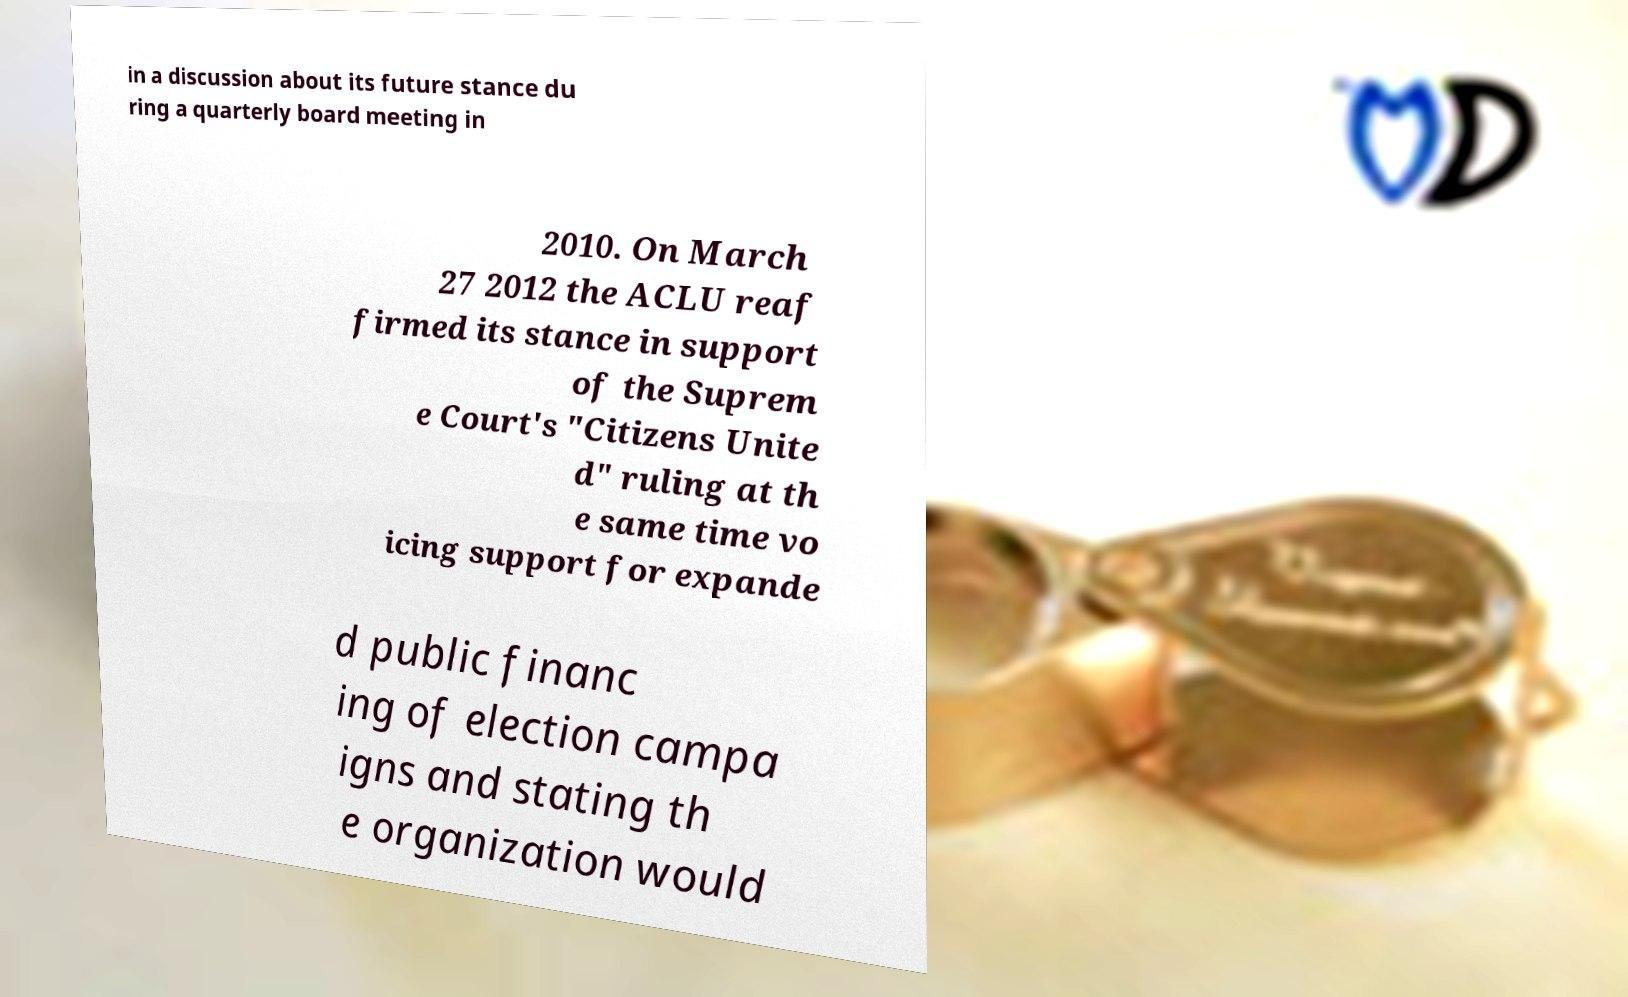What messages or text are displayed in this image? I need them in a readable, typed format. in a discussion about its future stance du ring a quarterly board meeting in 2010. On March 27 2012 the ACLU reaf firmed its stance in support of the Suprem e Court's "Citizens Unite d" ruling at th e same time vo icing support for expande d public financ ing of election campa igns and stating th e organization would 